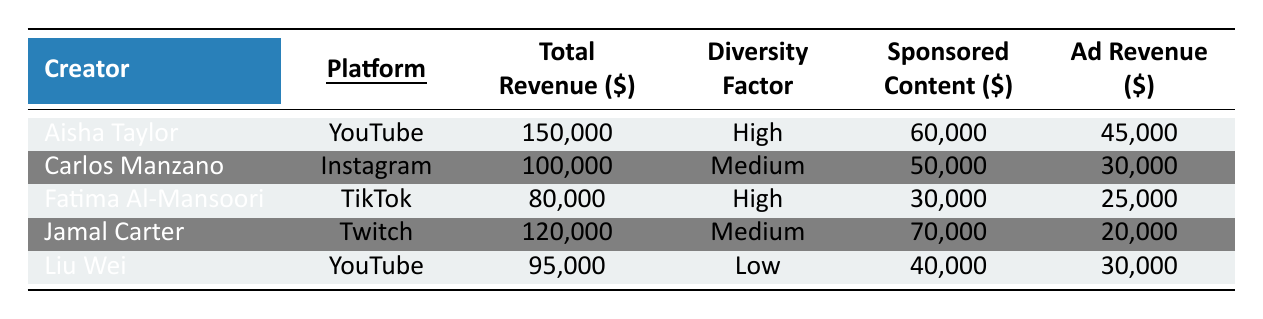What is the total revenue generated by Aisha Taylor? Aisha Taylor's total revenue is clearly stated as $150,000 in the table.
Answer: 150,000 Which creator has the highest sponsored content revenue? Aisha Taylor has the highest sponsored content revenue at $60,000, which is the highest value listed in the corresponding column.
Answer: Aisha Taylor What are the revenue breakdown components for Carlos Manzano? Carlos Manzano's revenue breakdown includes sponsored content ($50,000), ad revenue ($30,000), merchandising ($15,000), and affiliate links ($5,000), as detailed in the table.
Answer: $50,000, $30,000, $15,000, $5,000 Is the diversity factor of Liu Wei low? Yes, the table indicates that Liu Wei has a diversity factor classified as "Low."
Answer: Yes What is the average total revenue of high diversity factor creators? There are two high diversity factor creators: Aisha Taylor and Fatima Al-Mansoori. Their total revenues are $150,000 and $80,000, respectively. The sum is $230,000, and the average is $230,000 / 2 = $115,000.
Answer: 115,000 Which platform has the highest total revenue among the creators listed? Aisha Taylor, who operates on YouTube, generates the highest total revenue of $150,000, more than any other creator on the different platforms listed.
Answer: YouTube How much more does Jamal Carter earn from sponsored content compared to Fatima Al-Mansoori? Jamal Carter earns $70,000 from sponsored content, while Fatima Al-Mansoori earns $30,000. The difference is $70,000 - $30,000 = $40,000.
Answer: 40,000 Does TikTok have a creator with a medium diversity factor? No, according to the table, all the TikTok creators (Fatima Al-Mansoori) have a high diversity factor, thus no creators from that platform have a medium diversity factor.
Answer: No What is the total revenue from affiliate links across all creators? The affiliates links revenue for all creators adds up as follows: Aisha Taylor ($15,000) + Carlos Manzano ($5,000) + Fatima Al-Mansoori ($15,000) + Jamal Carter ($5,000) + Liu Wei ($5,000) = $45,000.
Answer: 45,000 Which creator has the lowest total revenue and what is the amount? Fatima Al-Mansoori has the lowest total revenue at $80,000, which is the smallest figure shown in the total revenue column.
Answer: Fatima Al-Mansoori, $80,000 